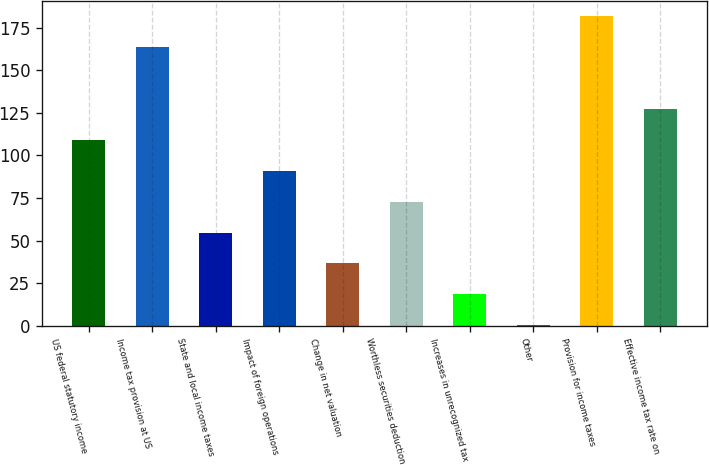Convert chart to OTSL. <chart><loc_0><loc_0><loc_500><loc_500><bar_chart><fcel>US federal statutory income<fcel>Income tax provision at US<fcel>State and local income taxes<fcel>Impact of foreign operations<fcel>Change in net valuation<fcel>Worthless securities deduction<fcel>Increases in unrecognized tax<fcel>Other<fcel>Provision for income taxes<fcel>Effective income tax rate on<nl><fcel>108.96<fcel>163.8<fcel>54.78<fcel>90.9<fcel>36.72<fcel>72.84<fcel>18.66<fcel>0.6<fcel>181.86<fcel>127.02<nl></chart> 